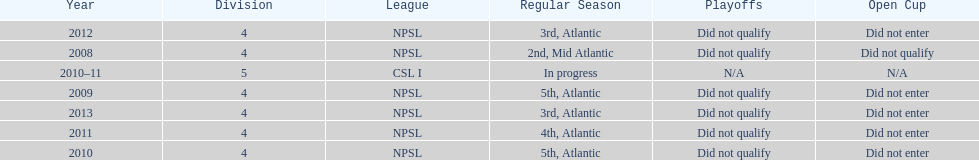Parse the table in full. {'header': ['Year', 'Division', 'League', 'Regular Season', 'Playoffs', 'Open Cup'], 'rows': [['2012', '4', 'NPSL', '3rd, Atlantic', 'Did not qualify', 'Did not enter'], ['2008', '4', 'NPSL', '2nd, Mid Atlantic', 'Did not qualify', 'Did not qualify'], ['2010–11', '5', 'CSL I', 'In progress', 'N/A', 'N/A'], ['2009', '4', 'NPSL', '5th, Atlantic', 'Did not qualify', 'Did not enter'], ['2013', '4', 'NPSL', '3rd, Atlantic', 'Did not qualify', 'Did not enter'], ['2011', '4', 'NPSL', '4th, Atlantic', 'Did not qualify', 'Did not enter'], ['2010', '4', 'NPSL', '5th, Atlantic', 'Did not qualify', 'Did not enter']]} How many 3rd place finishes has npsl had? 2. 